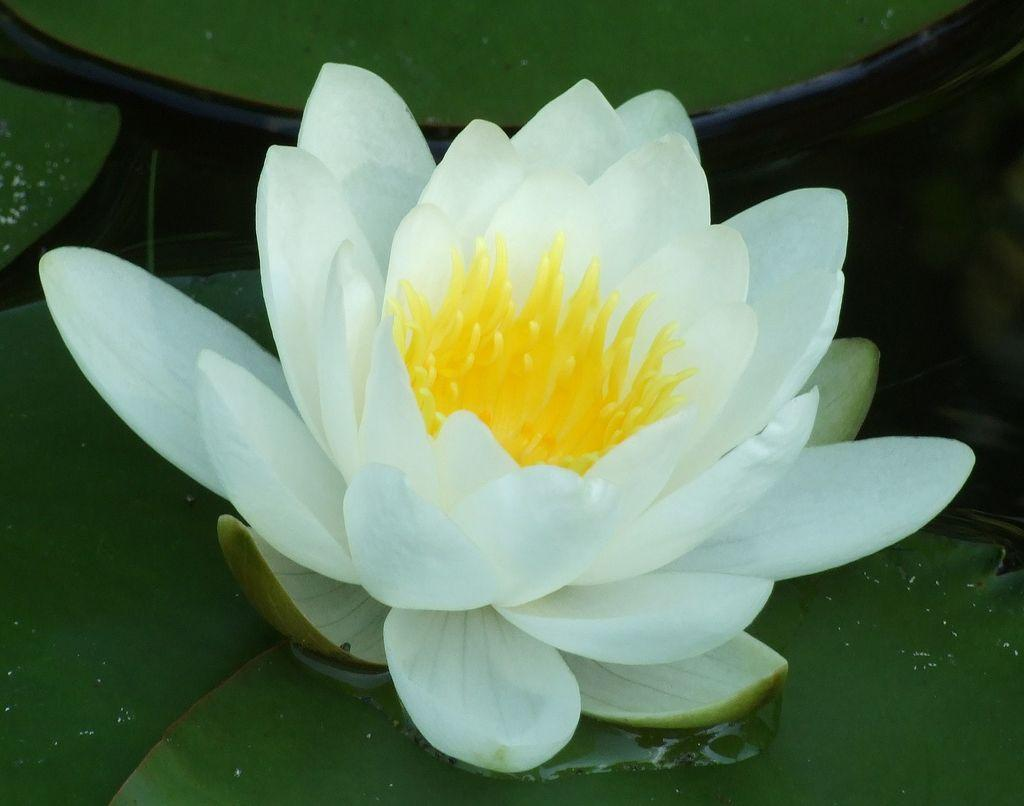What type of flower is in the image? There is a yellow and white flower in the image. What color are the leaves in the background of the image? The leaves in the background of the image are green. What letter does the brain spell out in the image? There is no brain or letter present in the image. 